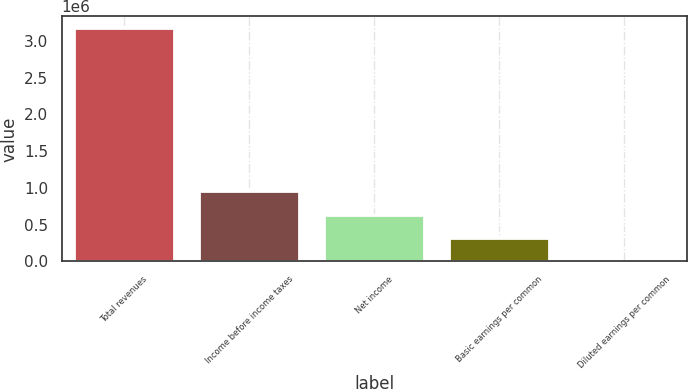<chart> <loc_0><loc_0><loc_500><loc_500><bar_chart><fcel>Total revenues<fcel>Income before income taxes<fcel>Net income<fcel>Basic earnings per common<fcel>Diluted earnings per common<nl><fcel>3.17627e+06<fcel>952882<fcel>635255<fcel>317628<fcel>0.52<nl></chart> 